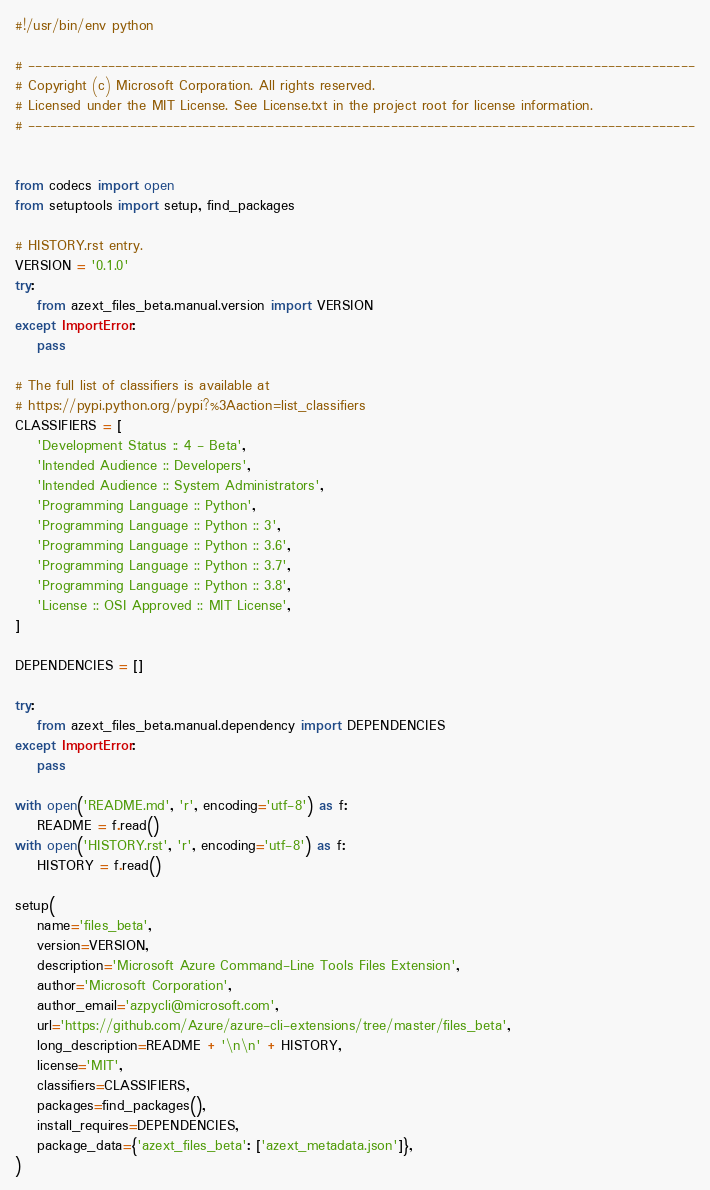<code> <loc_0><loc_0><loc_500><loc_500><_Python_>#!/usr/bin/env python

# --------------------------------------------------------------------------------------------
# Copyright (c) Microsoft Corporation. All rights reserved.
# Licensed under the MIT License. See License.txt in the project root for license information.
# --------------------------------------------------------------------------------------------


from codecs import open
from setuptools import setup, find_packages

# HISTORY.rst entry.
VERSION = '0.1.0'
try:
    from azext_files_beta.manual.version import VERSION
except ImportError:
    pass

# The full list of classifiers is available at
# https://pypi.python.org/pypi?%3Aaction=list_classifiers
CLASSIFIERS = [
    'Development Status :: 4 - Beta',
    'Intended Audience :: Developers',
    'Intended Audience :: System Administrators',
    'Programming Language :: Python',
    'Programming Language :: Python :: 3',
    'Programming Language :: Python :: 3.6',
    'Programming Language :: Python :: 3.7',
    'Programming Language :: Python :: 3.8',
    'License :: OSI Approved :: MIT License',
]

DEPENDENCIES = []

try:
    from azext_files_beta.manual.dependency import DEPENDENCIES
except ImportError:
    pass

with open('README.md', 'r', encoding='utf-8') as f:
    README = f.read()
with open('HISTORY.rst', 'r', encoding='utf-8') as f:
    HISTORY = f.read()

setup(
    name='files_beta',
    version=VERSION,
    description='Microsoft Azure Command-Line Tools Files Extension',
    author='Microsoft Corporation',
    author_email='azpycli@microsoft.com',
    url='https://github.com/Azure/azure-cli-extensions/tree/master/files_beta',
    long_description=README + '\n\n' + HISTORY,
    license='MIT',
    classifiers=CLASSIFIERS,
    packages=find_packages(),
    install_requires=DEPENDENCIES,
    package_data={'azext_files_beta': ['azext_metadata.json']},
)
</code> 